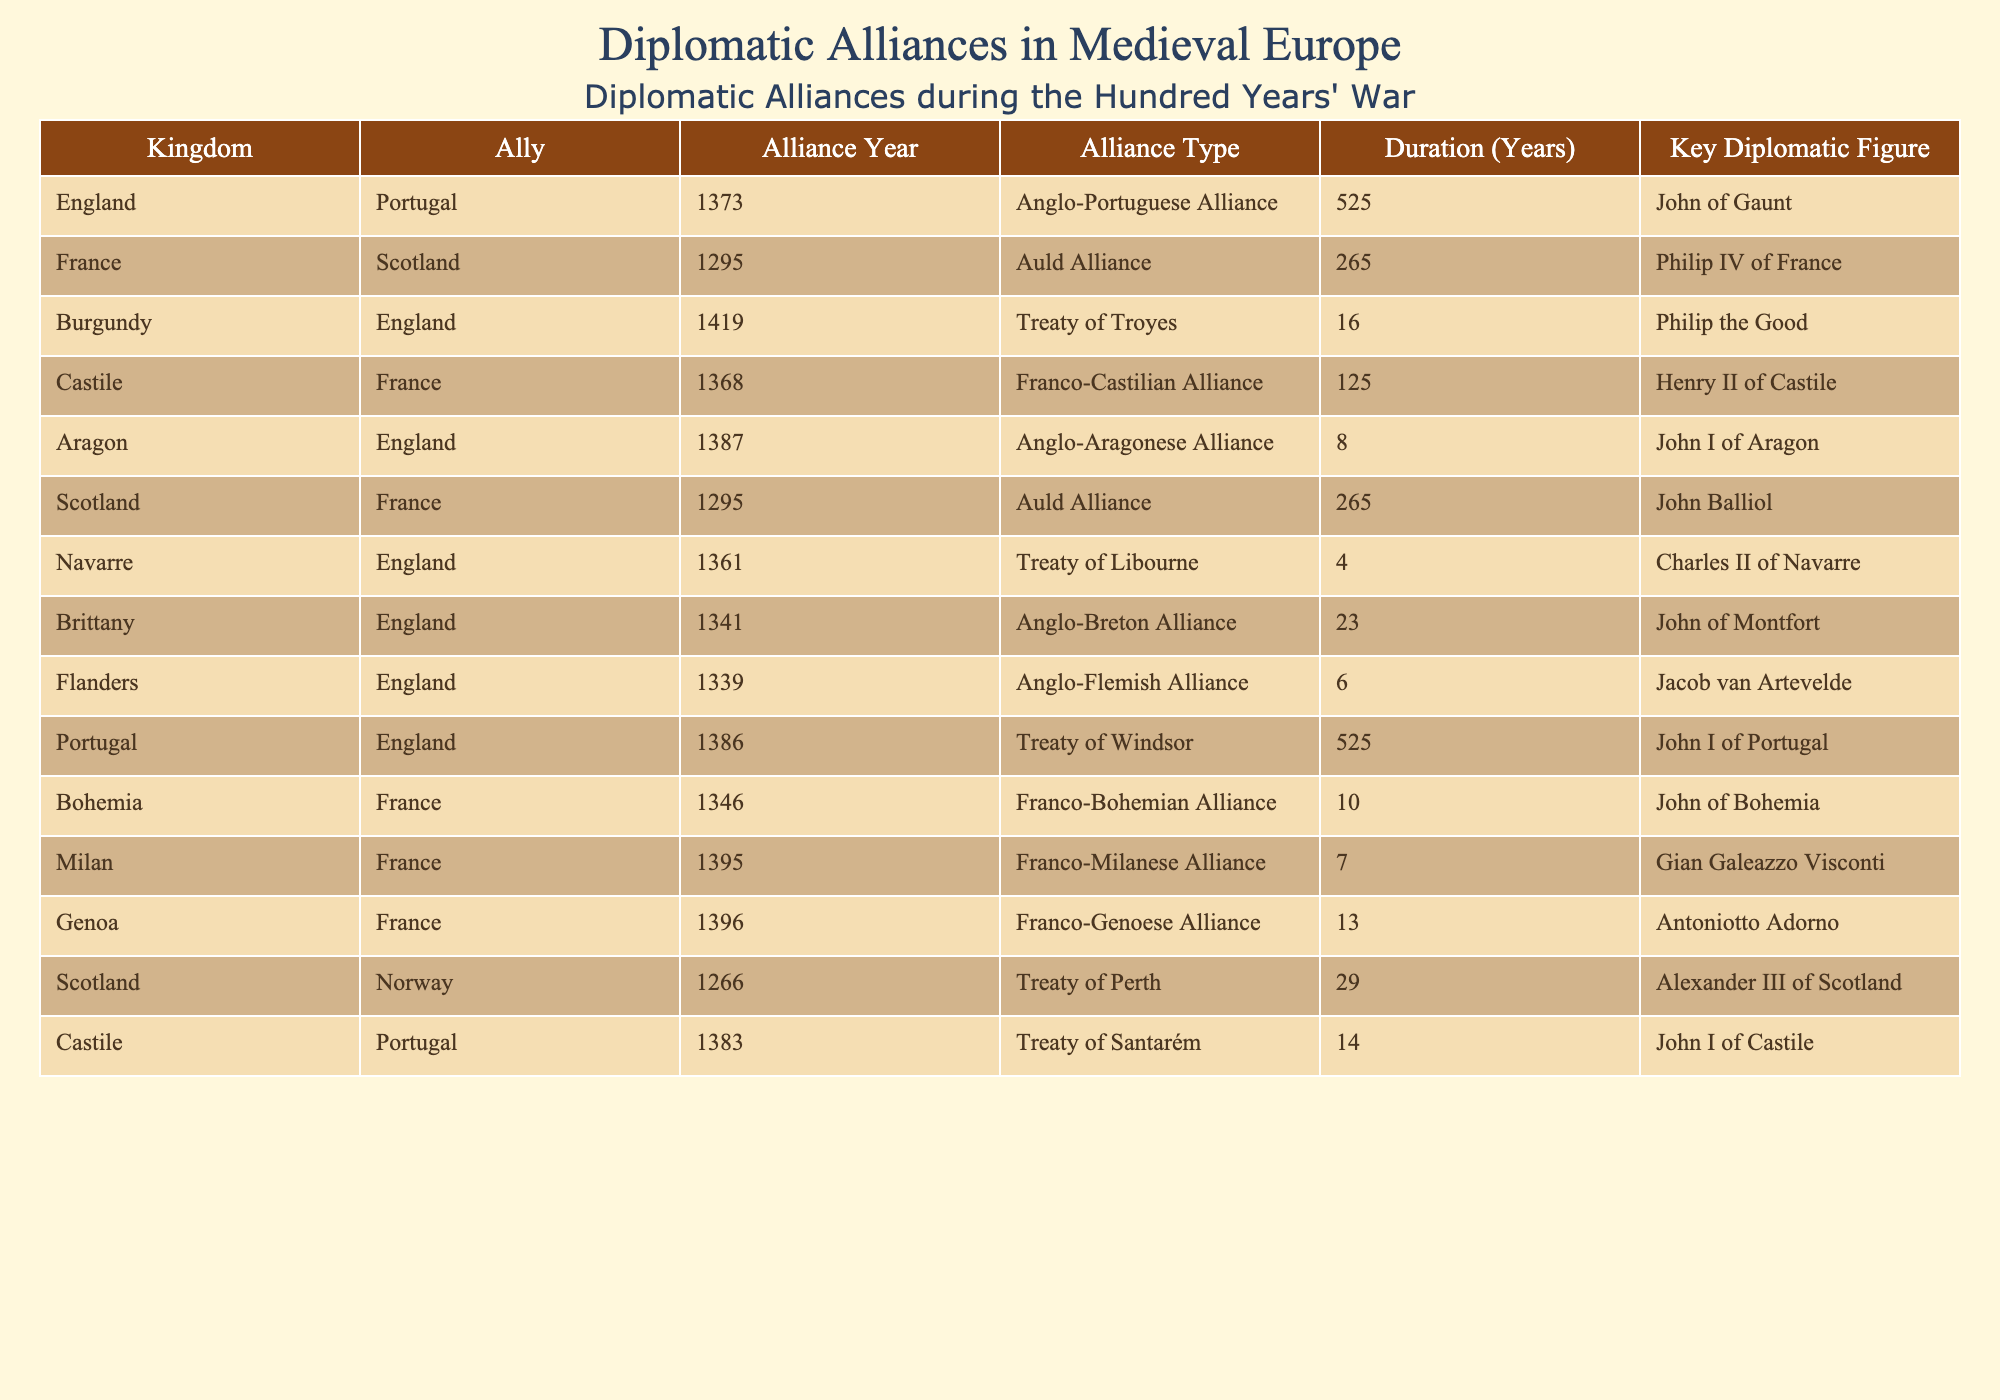What kingdom formed an alliance with England in 1373? The table lists the alliances and their corresponding years. In 1373, England formed an alliance with Portugal.
Answer: Portugal How long did the Auld Alliance between France and Scotland last? The table indicates that the Auld Alliance began in 1295 and lasted for 265 years.
Answer: 265 years Which diplomatic figure represented the Treaty of Troyes in 1419? The table shows that Philip the Good was the key diplomatic figure for the Treaty of Troyes, which was formed in 1419 between Burgundy and England.
Answer: Philip the Good Is the Anglo-Aragonese Alliance longer than the Franco-Genoese Alliance? The Anglo-Aragonese Alliance lasted for 8 years while the Franco-Genoese Alliance lasted for 13 years. Therefore, the statement is false.
Answer: No What is the sum of the durations of the Anglo-Portuguese Alliance and the Treaty of Windsor? The Anglo-Portuguese Alliance has a duration of 525 years, and the Treaty of Windsor has the same duration, so the sum is 525 + 525 = 1050 years.
Answer: 1050 years Which kingdom had the shortest alliance duration with England in the table? Navarre formed a treaty with England in 1361, with the duration being only 4 years, which is less than any other listed alliances with England.
Answer: Navarre If we consider all alliances involving France, what is the average duration of these alliances? The durations for the alliances involving France are 265 (Scotland), 125 (Castile), 10 (Bohemia), 7 (Milan), and 13 (Genoa). The total duration is 265 + 125 + 10 + 7 + 13 = 420 years. There are 5 alliances, so the average is 420 / 5 = 84 years.
Answer: 84 years Which kingdom had alliances with England in both 1341 and 1386? Referring to the table, both the Anglo-Breton Alliance in 1341 and the Treaty of Windsor in 1386 involved England and Brittany, confirming that Brittany is the answer.
Answer: Brittany What is the key diplomatic figure associated with the Franco-Castilian Alliance? The table reveals that Henry II of Castile is the key figure for the Franco-Castilian Alliance established in 1368.
Answer: Henry II of Castile 